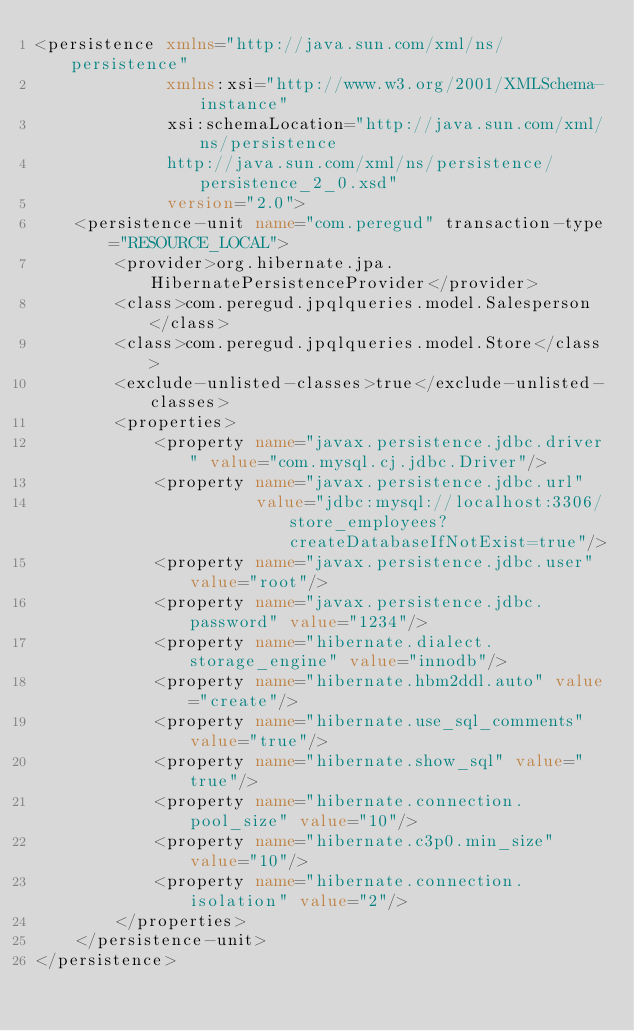<code> <loc_0><loc_0><loc_500><loc_500><_XML_><persistence xmlns="http://java.sun.com/xml/ns/persistence"
             xmlns:xsi="http://www.w3.org/2001/XMLSchema-instance"
             xsi:schemaLocation="http://java.sun.com/xml/ns/persistence
             http://java.sun.com/xml/ns/persistence/persistence_2_0.xsd"
             version="2.0">
    <persistence-unit name="com.peregud" transaction-type="RESOURCE_LOCAL">
        <provider>org.hibernate.jpa.HibernatePersistenceProvider</provider>
        <class>com.peregud.jpqlqueries.model.Salesperson</class>
        <class>com.peregud.jpqlqueries.model.Store</class>
        <exclude-unlisted-classes>true</exclude-unlisted-classes>
        <properties>
            <property name="javax.persistence.jdbc.driver" value="com.mysql.cj.jdbc.Driver"/>
            <property name="javax.persistence.jdbc.url"
                      value="jdbc:mysql://localhost:3306/store_employees?createDatabaseIfNotExist=true"/>
            <property name="javax.persistence.jdbc.user" value="root"/>
            <property name="javax.persistence.jdbc.password" value="1234"/>
            <property name="hibernate.dialect.storage_engine" value="innodb"/>
            <property name="hibernate.hbm2ddl.auto" value="create"/>
            <property name="hibernate.use_sql_comments" value="true"/>
            <property name="hibernate.show_sql" value="true"/>
            <property name="hibernate.connection.pool_size" value="10"/>
            <property name="hibernate.c3p0.min_size" value="10"/>
            <property name="hibernate.connection.isolation" value="2"/>
        </properties>
    </persistence-unit>
</persistence>
</code> 